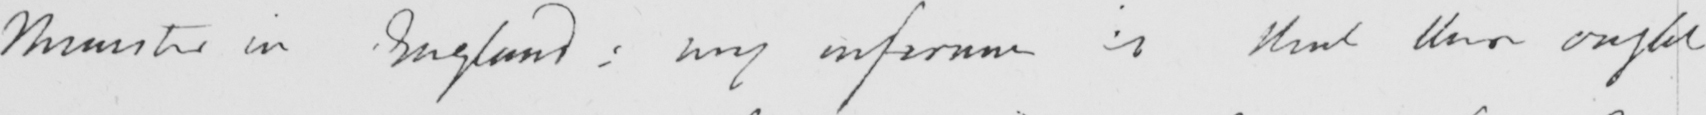Please transcribe the handwritten text in this image. Minister in England :  my inference is that there ought 